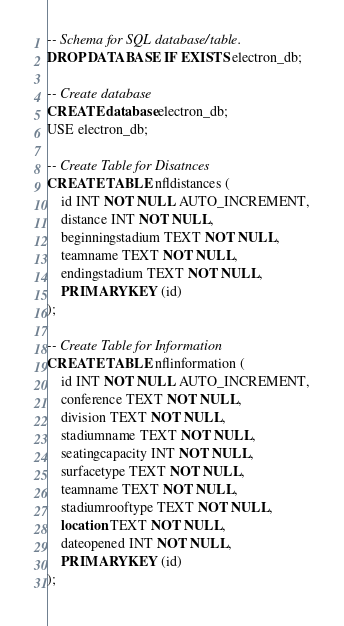Convert code to text. <code><loc_0><loc_0><loc_500><loc_500><_SQL_>-- Schema for SQL database/table.
DROP DATABASE IF EXISTS electron_db;

-- Create database
CREATE database electron_db;
USE electron_db;

-- Create Table for Disatnces
CREATE TABLE nfldistances (
    id INT NOT NULL AUTO_INCREMENT,
    distance INT NOT NULL,
    beginningstadium TEXT NOT NULL,
    teamname TEXT NOT NULL,
    endingstadium TEXT NOT NULL,
    PRIMARY KEY (id)
);

-- Create Table for Information
CREATE TABLE nflinformation (
    id INT NOT NULL AUTO_INCREMENT,
    conference TEXT NOT NULL,
    division TEXT NOT NULL,
    stadiumname TEXT NOT NULL,
    seatingcapacity INT NOT NULL,
    surfacetype TEXT NOT NULL,
    teamname TEXT NOT NULL,
    stadiumrooftype TEXT NOT NULL,
    location TEXT NOT NULL,
    dateopened INT NOT NULL,
    PRIMARY KEY (id)
);
</code> 